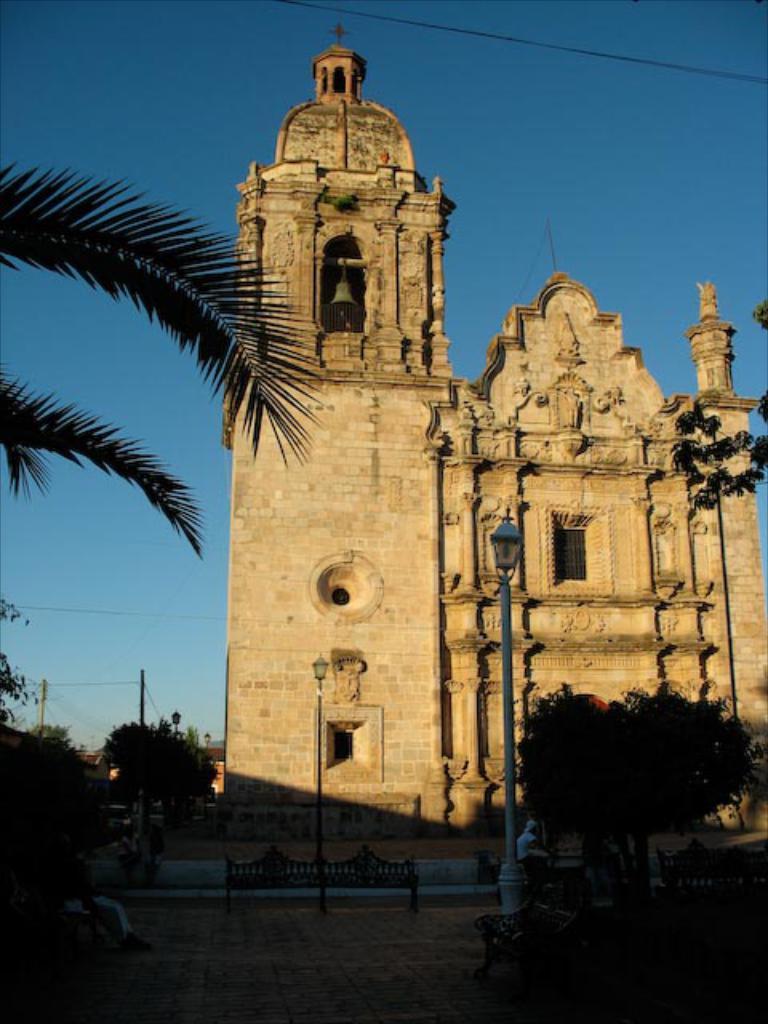Can you describe this image briefly? In this image in the center there are persons and there are empty bench, there are poles, trees. In the background there are buildings and there are poles. 